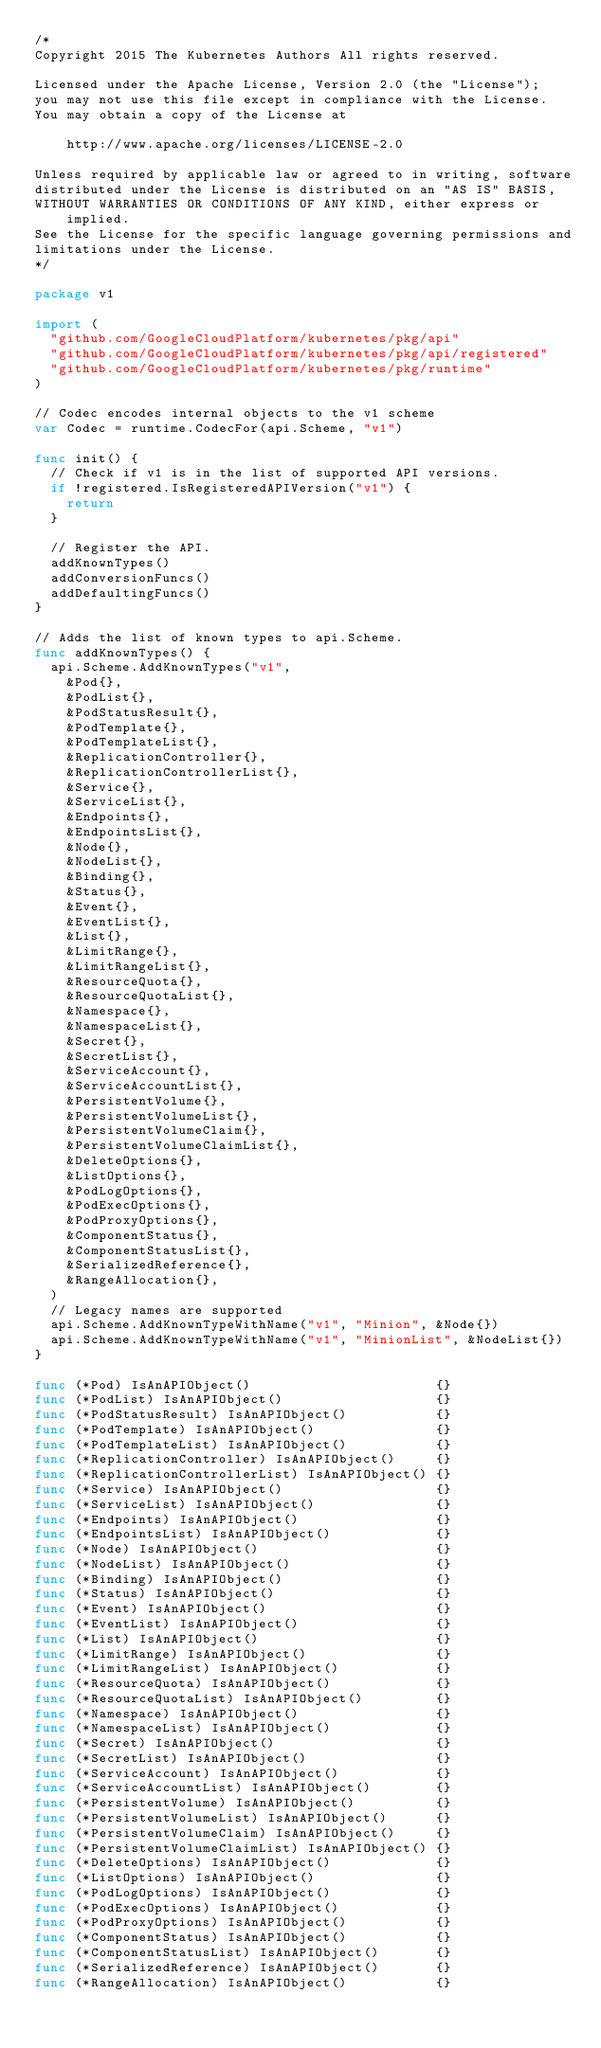Convert code to text. <code><loc_0><loc_0><loc_500><loc_500><_Go_>/*
Copyright 2015 The Kubernetes Authors All rights reserved.

Licensed under the Apache License, Version 2.0 (the "License");
you may not use this file except in compliance with the License.
You may obtain a copy of the License at

    http://www.apache.org/licenses/LICENSE-2.0

Unless required by applicable law or agreed to in writing, software
distributed under the License is distributed on an "AS IS" BASIS,
WITHOUT WARRANTIES OR CONDITIONS OF ANY KIND, either express or implied.
See the License for the specific language governing permissions and
limitations under the License.
*/

package v1

import (
	"github.com/GoogleCloudPlatform/kubernetes/pkg/api"
	"github.com/GoogleCloudPlatform/kubernetes/pkg/api/registered"
	"github.com/GoogleCloudPlatform/kubernetes/pkg/runtime"
)

// Codec encodes internal objects to the v1 scheme
var Codec = runtime.CodecFor(api.Scheme, "v1")

func init() {
	// Check if v1 is in the list of supported API versions.
	if !registered.IsRegisteredAPIVersion("v1") {
		return
	}

	// Register the API.
	addKnownTypes()
	addConversionFuncs()
	addDefaultingFuncs()
}

// Adds the list of known types to api.Scheme.
func addKnownTypes() {
	api.Scheme.AddKnownTypes("v1",
		&Pod{},
		&PodList{},
		&PodStatusResult{},
		&PodTemplate{},
		&PodTemplateList{},
		&ReplicationController{},
		&ReplicationControllerList{},
		&Service{},
		&ServiceList{},
		&Endpoints{},
		&EndpointsList{},
		&Node{},
		&NodeList{},
		&Binding{},
		&Status{},
		&Event{},
		&EventList{},
		&List{},
		&LimitRange{},
		&LimitRangeList{},
		&ResourceQuota{},
		&ResourceQuotaList{},
		&Namespace{},
		&NamespaceList{},
		&Secret{},
		&SecretList{},
		&ServiceAccount{},
		&ServiceAccountList{},
		&PersistentVolume{},
		&PersistentVolumeList{},
		&PersistentVolumeClaim{},
		&PersistentVolumeClaimList{},
		&DeleteOptions{},
		&ListOptions{},
		&PodLogOptions{},
		&PodExecOptions{},
		&PodProxyOptions{},
		&ComponentStatus{},
		&ComponentStatusList{},
		&SerializedReference{},
		&RangeAllocation{},
	)
	// Legacy names are supported
	api.Scheme.AddKnownTypeWithName("v1", "Minion", &Node{})
	api.Scheme.AddKnownTypeWithName("v1", "MinionList", &NodeList{})
}

func (*Pod) IsAnAPIObject()                       {}
func (*PodList) IsAnAPIObject()                   {}
func (*PodStatusResult) IsAnAPIObject()           {}
func (*PodTemplate) IsAnAPIObject()               {}
func (*PodTemplateList) IsAnAPIObject()           {}
func (*ReplicationController) IsAnAPIObject()     {}
func (*ReplicationControllerList) IsAnAPIObject() {}
func (*Service) IsAnAPIObject()                   {}
func (*ServiceList) IsAnAPIObject()               {}
func (*Endpoints) IsAnAPIObject()                 {}
func (*EndpointsList) IsAnAPIObject()             {}
func (*Node) IsAnAPIObject()                      {}
func (*NodeList) IsAnAPIObject()                  {}
func (*Binding) IsAnAPIObject()                   {}
func (*Status) IsAnAPIObject()                    {}
func (*Event) IsAnAPIObject()                     {}
func (*EventList) IsAnAPIObject()                 {}
func (*List) IsAnAPIObject()                      {}
func (*LimitRange) IsAnAPIObject()                {}
func (*LimitRangeList) IsAnAPIObject()            {}
func (*ResourceQuota) IsAnAPIObject()             {}
func (*ResourceQuotaList) IsAnAPIObject()         {}
func (*Namespace) IsAnAPIObject()                 {}
func (*NamespaceList) IsAnAPIObject()             {}
func (*Secret) IsAnAPIObject()                    {}
func (*SecretList) IsAnAPIObject()                {}
func (*ServiceAccount) IsAnAPIObject()            {}
func (*ServiceAccountList) IsAnAPIObject()        {}
func (*PersistentVolume) IsAnAPIObject()          {}
func (*PersistentVolumeList) IsAnAPIObject()      {}
func (*PersistentVolumeClaim) IsAnAPIObject()     {}
func (*PersistentVolumeClaimList) IsAnAPIObject() {}
func (*DeleteOptions) IsAnAPIObject()             {}
func (*ListOptions) IsAnAPIObject()               {}
func (*PodLogOptions) IsAnAPIObject()             {}
func (*PodExecOptions) IsAnAPIObject()            {}
func (*PodProxyOptions) IsAnAPIObject()           {}
func (*ComponentStatus) IsAnAPIObject()           {}
func (*ComponentStatusList) IsAnAPIObject()       {}
func (*SerializedReference) IsAnAPIObject()       {}
func (*RangeAllocation) IsAnAPIObject()           {}
</code> 